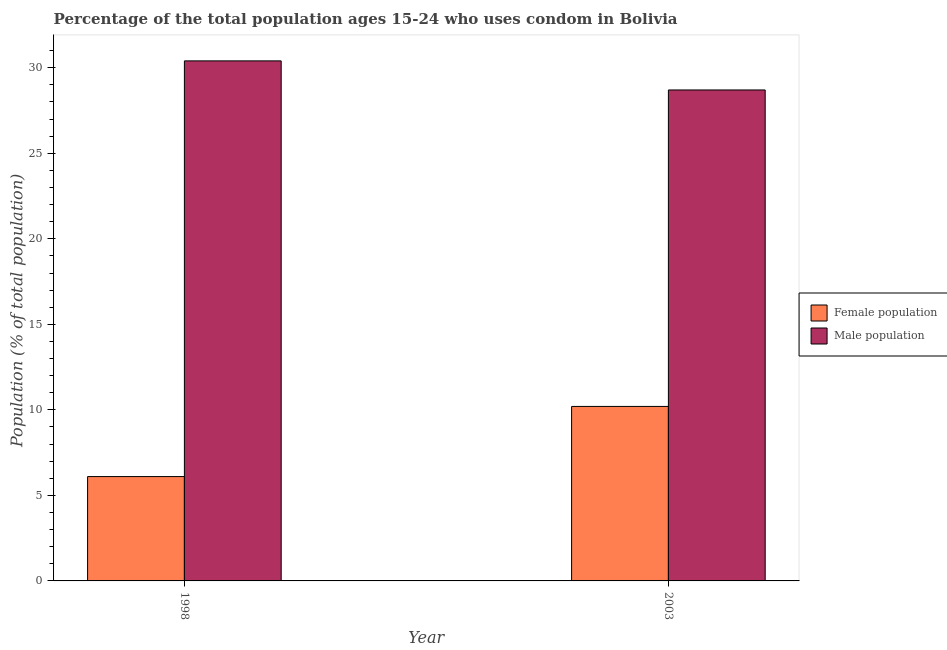Are the number of bars on each tick of the X-axis equal?
Keep it short and to the point. Yes. How many bars are there on the 1st tick from the left?
Offer a terse response. 2. What is the male population in 2003?
Provide a succinct answer. 28.7. Across all years, what is the maximum male population?
Your answer should be very brief. 30.4. Across all years, what is the minimum male population?
Keep it short and to the point. 28.7. What is the total male population in the graph?
Offer a very short reply. 59.1. What is the difference between the male population in 1998 and that in 2003?
Your answer should be very brief. 1.7. What is the difference between the female population in 1998 and the male population in 2003?
Give a very brief answer. -4.1. What is the average female population per year?
Give a very brief answer. 8.15. In the year 2003, what is the difference between the male population and female population?
Ensure brevity in your answer.  0. What is the ratio of the female population in 1998 to that in 2003?
Your answer should be compact. 0.6. Is the male population in 1998 less than that in 2003?
Your answer should be compact. No. In how many years, is the male population greater than the average male population taken over all years?
Your answer should be compact. 1. What does the 2nd bar from the left in 2003 represents?
Give a very brief answer. Male population. What does the 1st bar from the right in 1998 represents?
Give a very brief answer. Male population. How many bars are there?
Provide a short and direct response. 4. What is the difference between two consecutive major ticks on the Y-axis?
Your response must be concise. 5. Are the values on the major ticks of Y-axis written in scientific E-notation?
Offer a very short reply. No. Does the graph contain grids?
Provide a short and direct response. No. Where does the legend appear in the graph?
Your answer should be compact. Center right. What is the title of the graph?
Provide a succinct answer. Percentage of the total population ages 15-24 who uses condom in Bolivia. Does "Urban Population" appear as one of the legend labels in the graph?
Your response must be concise. No. What is the label or title of the X-axis?
Offer a terse response. Year. What is the label or title of the Y-axis?
Your response must be concise. Population (% of total population) . What is the Population (% of total population)  of Female population in 1998?
Offer a very short reply. 6.1. What is the Population (% of total population)  in Male population in 1998?
Your answer should be compact. 30.4. What is the Population (% of total population)  of Male population in 2003?
Your response must be concise. 28.7. Across all years, what is the maximum Population (% of total population)  of Male population?
Provide a short and direct response. 30.4. Across all years, what is the minimum Population (% of total population)  of Female population?
Ensure brevity in your answer.  6.1. Across all years, what is the minimum Population (% of total population)  of Male population?
Your response must be concise. 28.7. What is the total Population (% of total population)  of Female population in the graph?
Make the answer very short. 16.3. What is the total Population (% of total population)  of Male population in the graph?
Give a very brief answer. 59.1. What is the difference between the Population (% of total population)  in Female population in 1998 and that in 2003?
Offer a terse response. -4.1. What is the difference between the Population (% of total population)  of Male population in 1998 and that in 2003?
Ensure brevity in your answer.  1.7. What is the difference between the Population (% of total population)  of Female population in 1998 and the Population (% of total population)  of Male population in 2003?
Provide a short and direct response. -22.6. What is the average Population (% of total population)  in Female population per year?
Give a very brief answer. 8.15. What is the average Population (% of total population)  in Male population per year?
Your response must be concise. 29.55. In the year 1998, what is the difference between the Population (% of total population)  in Female population and Population (% of total population)  in Male population?
Ensure brevity in your answer.  -24.3. In the year 2003, what is the difference between the Population (% of total population)  in Female population and Population (% of total population)  in Male population?
Offer a very short reply. -18.5. What is the ratio of the Population (% of total population)  of Female population in 1998 to that in 2003?
Provide a short and direct response. 0.6. What is the ratio of the Population (% of total population)  of Male population in 1998 to that in 2003?
Provide a succinct answer. 1.06. What is the difference between the highest and the second highest Population (% of total population)  in Female population?
Make the answer very short. 4.1. What is the difference between the highest and the lowest Population (% of total population)  in Female population?
Ensure brevity in your answer.  4.1. What is the difference between the highest and the lowest Population (% of total population)  of Male population?
Provide a short and direct response. 1.7. 